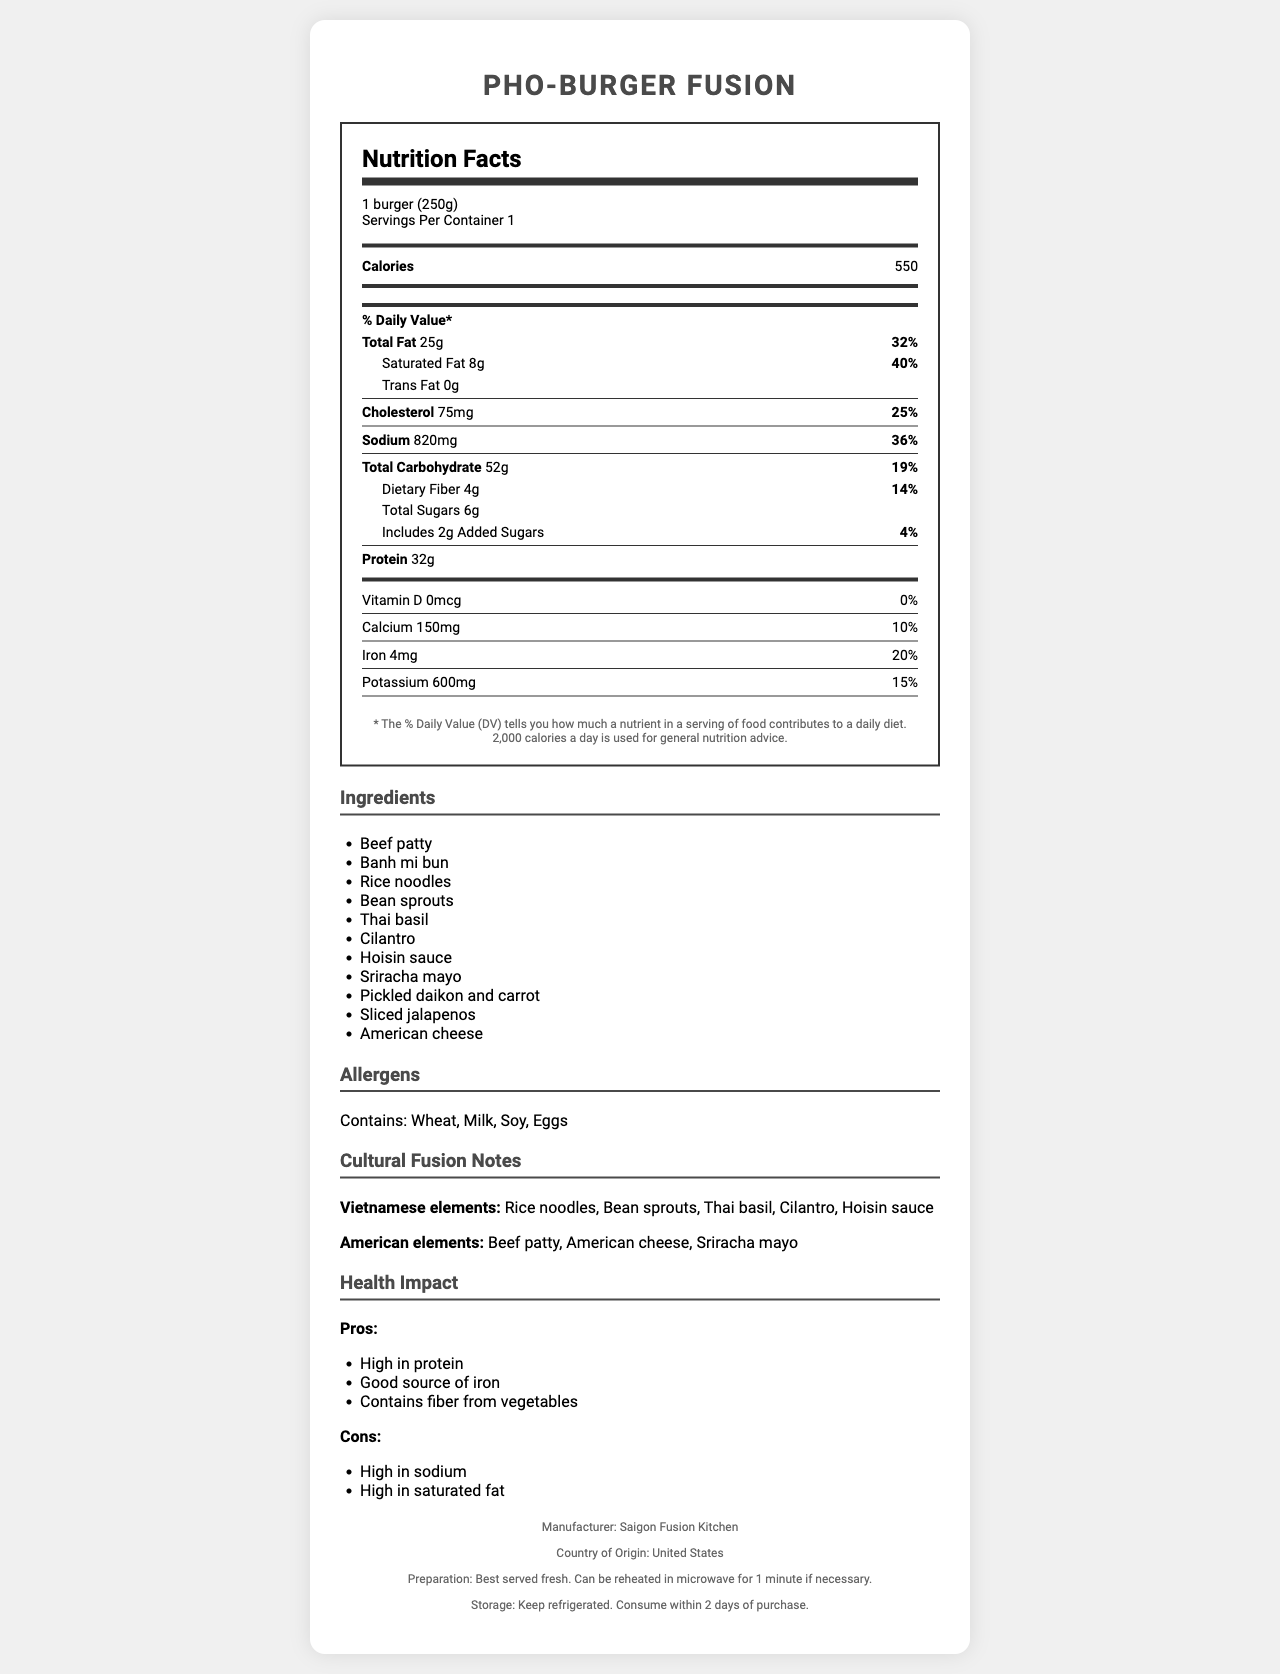what is the serving size of Pho-Burger Fusion? The serving size is explicitly mentioned as "1 burger (250g)" in the document.
Answer: 1 burger (250g) how many calories are in one serving of Pho-Burger Fusion? The calorie count is listed as 550 in the document.
Answer: 550 what are the main allergens present in this dish? The document states the allergens under the "Allergens" section.
Answer: Wheat, Milk, Soy, Eggs what is the total fat content and its daily value percentage? The total fat content is 25g with a daily value percentage of 32%, as listed in the document.
Answer: 25g, 32% list two Vietnamese elements in the dish. The document specifies these as Vietnamese elements under the "Cultural Fusion Notes" section.
Answer: Rice noodles, Bean sprouts how much saturated fat is there per serving? The document notes that there is 8g of saturated fat per serving.
Answer: 8g what is the protein content of this dish? The protein content is listed as 32g in the document.
Answer: 32g how much dietary fiber does this dish contain? A. 2g B. 4g C. 6g D. 8g The document lists the dietary fiber content as 4g.
Answer: B. 4g which nutrient has the highest daily value percentage? A. Sodium B. Saturated Fat C. Protein D. Calcium Saturated Fat has the highest daily value percentage at 40%.
Answer: B. Saturated Fat is the dish high in sodium? The sodium content is 820mg, which is 36% of the daily value, making it high in sodium.
Answer: Yes describe the cultural fusion elements of the Pho-Burger Fusion. The document outlines the specific Vietnamese and American elements under the "Cultural Fusion Notes" section, providing a blend of cultural flavors.
Answer: The Pho-Burger Fusion combines Vietnamese elements like rice noodles, bean sprouts, Thai basil, cilantro, and hoisin sauce with American elements such as a beef patty, American cheese, and sriracha mayo. what is the shelf life of the dish? The document states storage instructions but does not provide the exact shelf life duration beyond consuming within 2 days of purchase.
Answer: Not enough information what is the main source of protein in the dish? The ingredients list contains a beef patty, which is a common and significant source of protein.
Answer: Beef patty what should you do if you want to eat the dish later and it has been refrigerated? The preparation instructions state that the dish can be reheated in the microwave for 1 minute if necessary.
Answer: Reheat it in the microwave for 1 minute. 